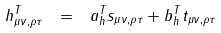Convert formula to latex. <formula><loc_0><loc_0><loc_500><loc_500>h ^ { T } _ { \mu \nu , \rho \tau } \ = \ a ^ { T } _ { h } s _ { \mu \nu , \rho \tau } + b ^ { T } _ { h } t _ { \mu \nu , \rho \tau }</formula> 